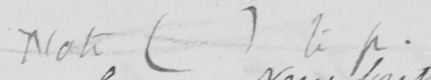What is written in this line of handwriting? Note ( ) to p. 